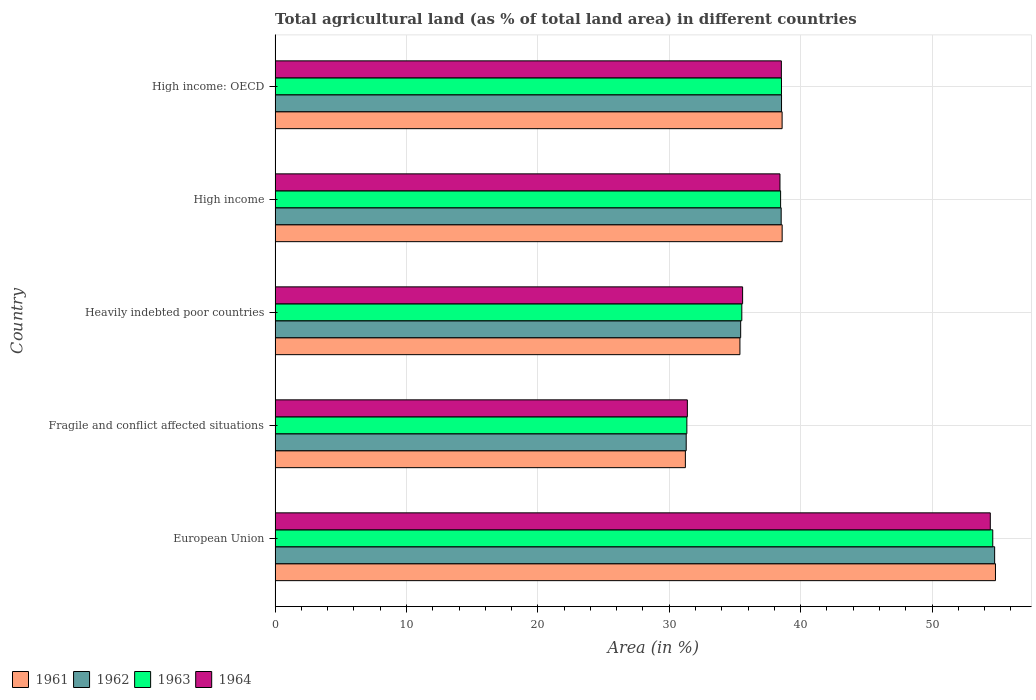How many different coloured bars are there?
Your response must be concise. 4. Are the number of bars on each tick of the Y-axis equal?
Your answer should be very brief. Yes. How many bars are there on the 5th tick from the top?
Your response must be concise. 4. What is the label of the 1st group of bars from the top?
Give a very brief answer. High income: OECD. In how many cases, is the number of bars for a given country not equal to the number of legend labels?
Your answer should be very brief. 0. What is the percentage of agricultural land in 1961 in High income: OECD?
Your response must be concise. 38.59. Across all countries, what is the maximum percentage of agricultural land in 1961?
Your response must be concise. 54.83. Across all countries, what is the minimum percentage of agricultural land in 1961?
Ensure brevity in your answer.  31.23. In which country was the percentage of agricultural land in 1963 maximum?
Provide a short and direct response. European Union. In which country was the percentage of agricultural land in 1964 minimum?
Offer a very short reply. Fragile and conflict affected situations. What is the total percentage of agricultural land in 1964 in the graph?
Your answer should be compact. 198.37. What is the difference between the percentage of agricultural land in 1961 in Fragile and conflict affected situations and that in High income?
Your response must be concise. -7.37. What is the difference between the percentage of agricultural land in 1962 in Fragile and conflict affected situations and the percentage of agricultural land in 1963 in European Union?
Provide a succinct answer. -23.33. What is the average percentage of agricultural land in 1964 per country?
Your response must be concise. 39.67. What is the difference between the percentage of agricultural land in 1963 and percentage of agricultural land in 1962 in European Union?
Make the answer very short. -0.14. What is the ratio of the percentage of agricultural land in 1962 in European Union to that in High income?
Offer a very short reply. 1.42. Is the percentage of agricultural land in 1964 in Fragile and conflict affected situations less than that in High income?
Your response must be concise. Yes. Is the difference between the percentage of agricultural land in 1963 in European Union and High income: OECD greater than the difference between the percentage of agricultural land in 1962 in European Union and High income: OECD?
Keep it short and to the point. No. What is the difference between the highest and the second highest percentage of agricultural land in 1961?
Your answer should be very brief. 16.24. What is the difference between the highest and the lowest percentage of agricultural land in 1961?
Give a very brief answer. 23.6. What does the 1st bar from the top in High income: OECD represents?
Your answer should be compact. 1964. What does the 3rd bar from the bottom in Fragile and conflict affected situations represents?
Your answer should be compact. 1963. How many countries are there in the graph?
Offer a very short reply. 5. Are the values on the major ticks of X-axis written in scientific E-notation?
Ensure brevity in your answer.  No. Does the graph contain any zero values?
Your answer should be very brief. No. Does the graph contain grids?
Provide a succinct answer. Yes. Where does the legend appear in the graph?
Give a very brief answer. Bottom left. How are the legend labels stacked?
Your answer should be compact. Horizontal. What is the title of the graph?
Your answer should be very brief. Total agricultural land (as % of total land area) in different countries. What is the label or title of the X-axis?
Your answer should be very brief. Area (in %). What is the Area (in %) in 1961 in European Union?
Keep it short and to the point. 54.83. What is the Area (in %) in 1962 in European Union?
Provide a succinct answer. 54.77. What is the Area (in %) of 1963 in European Union?
Keep it short and to the point. 54.63. What is the Area (in %) in 1964 in European Union?
Offer a terse response. 54.44. What is the Area (in %) in 1961 in Fragile and conflict affected situations?
Provide a succinct answer. 31.23. What is the Area (in %) in 1962 in Fragile and conflict affected situations?
Provide a succinct answer. 31.29. What is the Area (in %) of 1963 in Fragile and conflict affected situations?
Provide a succinct answer. 31.34. What is the Area (in %) in 1964 in Fragile and conflict affected situations?
Offer a terse response. 31.38. What is the Area (in %) in 1961 in Heavily indebted poor countries?
Provide a short and direct response. 35.38. What is the Area (in %) in 1962 in Heavily indebted poor countries?
Give a very brief answer. 35.44. What is the Area (in %) in 1963 in Heavily indebted poor countries?
Give a very brief answer. 35.52. What is the Area (in %) in 1964 in Heavily indebted poor countries?
Give a very brief answer. 35.59. What is the Area (in %) of 1961 in High income?
Make the answer very short. 38.59. What is the Area (in %) in 1962 in High income?
Ensure brevity in your answer.  38.52. What is the Area (in %) of 1963 in High income?
Provide a short and direct response. 38.48. What is the Area (in %) of 1964 in High income?
Your response must be concise. 38.43. What is the Area (in %) in 1961 in High income: OECD?
Give a very brief answer. 38.59. What is the Area (in %) in 1962 in High income: OECD?
Ensure brevity in your answer.  38.55. What is the Area (in %) of 1963 in High income: OECD?
Provide a succinct answer. 38.54. What is the Area (in %) of 1964 in High income: OECD?
Provide a succinct answer. 38.53. Across all countries, what is the maximum Area (in %) of 1961?
Your answer should be compact. 54.83. Across all countries, what is the maximum Area (in %) of 1962?
Your response must be concise. 54.77. Across all countries, what is the maximum Area (in %) in 1963?
Offer a terse response. 54.63. Across all countries, what is the maximum Area (in %) of 1964?
Provide a short and direct response. 54.44. Across all countries, what is the minimum Area (in %) in 1961?
Provide a short and direct response. 31.23. Across all countries, what is the minimum Area (in %) in 1962?
Your answer should be very brief. 31.29. Across all countries, what is the minimum Area (in %) in 1963?
Your answer should be very brief. 31.34. Across all countries, what is the minimum Area (in %) in 1964?
Your answer should be compact. 31.38. What is the total Area (in %) of 1961 in the graph?
Give a very brief answer. 198.63. What is the total Area (in %) in 1962 in the graph?
Offer a very short reply. 198.57. What is the total Area (in %) of 1963 in the graph?
Provide a succinct answer. 198.51. What is the total Area (in %) in 1964 in the graph?
Offer a terse response. 198.37. What is the difference between the Area (in %) of 1961 in European Union and that in Fragile and conflict affected situations?
Provide a succinct answer. 23.6. What is the difference between the Area (in %) in 1962 in European Union and that in Fragile and conflict affected situations?
Ensure brevity in your answer.  23.48. What is the difference between the Area (in %) of 1963 in European Union and that in Fragile and conflict affected situations?
Keep it short and to the point. 23.28. What is the difference between the Area (in %) in 1964 in European Union and that in Fragile and conflict affected situations?
Provide a short and direct response. 23.06. What is the difference between the Area (in %) in 1961 in European Union and that in Heavily indebted poor countries?
Your response must be concise. 19.45. What is the difference between the Area (in %) in 1962 in European Union and that in Heavily indebted poor countries?
Offer a very short reply. 19.33. What is the difference between the Area (in %) in 1963 in European Union and that in Heavily indebted poor countries?
Ensure brevity in your answer.  19.1. What is the difference between the Area (in %) in 1964 in European Union and that in Heavily indebted poor countries?
Your answer should be compact. 18.85. What is the difference between the Area (in %) of 1961 in European Union and that in High income?
Provide a succinct answer. 16.24. What is the difference between the Area (in %) in 1962 in European Union and that in High income?
Your answer should be compact. 16.25. What is the difference between the Area (in %) of 1963 in European Union and that in High income?
Give a very brief answer. 16.15. What is the difference between the Area (in %) of 1964 in European Union and that in High income?
Provide a succinct answer. 16.01. What is the difference between the Area (in %) of 1961 in European Union and that in High income: OECD?
Your answer should be compact. 16.24. What is the difference between the Area (in %) of 1962 in European Union and that in High income: OECD?
Your answer should be very brief. 16.22. What is the difference between the Area (in %) in 1963 in European Union and that in High income: OECD?
Give a very brief answer. 16.08. What is the difference between the Area (in %) in 1964 in European Union and that in High income: OECD?
Make the answer very short. 15.9. What is the difference between the Area (in %) of 1961 in Fragile and conflict affected situations and that in Heavily indebted poor countries?
Offer a very short reply. -4.15. What is the difference between the Area (in %) of 1962 in Fragile and conflict affected situations and that in Heavily indebted poor countries?
Your answer should be very brief. -4.15. What is the difference between the Area (in %) of 1963 in Fragile and conflict affected situations and that in Heavily indebted poor countries?
Your answer should be compact. -4.18. What is the difference between the Area (in %) of 1964 in Fragile and conflict affected situations and that in Heavily indebted poor countries?
Give a very brief answer. -4.21. What is the difference between the Area (in %) of 1961 in Fragile and conflict affected situations and that in High income?
Make the answer very short. -7.37. What is the difference between the Area (in %) of 1962 in Fragile and conflict affected situations and that in High income?
Your answer should be very brief. -7.23. What is the difference between the Area (in %) of 1963 in Fragile and conflict affected situations and that in High income?
Offer a very short reply. -7.14. What is the difference between the Area (in %) in 1964 in Fragile and conflict affected situations and that in High income?
Your answer should be very brief. -7.05. What is the difference between the Area (in %) of 1961 in Fragile and conflict affected situations and that in High income: OECD?
Offer a very short reply. -7.36. What is the difference between the Area (in %) in 1962 in Fragile and conflict affected situations and that in High income: OECD?
Provide a succinct answer. -7.26. What is the difference between the Area (in %) in 1963 in Fragile and conflict affected situations and that in High income: OECD?
Ensure brevity in your answer.  -7.2. What is the difference between the Area (in %) in 1964 in Fragile and conflict affected situations and that in High income: OECD?
Your answer should be very brief. -7.15. What is the difference between the Area (in %) in 1961 in Heavily indebted poor countries and that in High income?
Offer a terse response. -3.21. What is the difference between the Area (in %) in 1962 in Heavily indebted poor countries and that in High income?
Provide a short and direct response. -3.08. What is the difference between the Area (in %) in 1963 in Heavily indebted poor countries and that in High income?
Make the answer very short. -2.95. What is the difference between the Area (in %) of 1964 in Heavily indebted poor countries and that in High income?
Your response must be concise. -2.84. What is the difference between the Area (in %) in 1961 in Heavily indebted poor countries and that in High income: OECD?
Your answer should be compact. -3.21. What is the difference between the Area (in %) of 1962 in Heavily indebted poor countries and that in High income: OECD?
Offer a terse response. -3.11. What is the difference between the Area (in %) in 1963 in Heavily indebted poor countries and that in High income: OECD?
Keep it short and to the point. -3.02. What is the difference between the Area (in %) of 1964 in Heavily indebted poor countries and that in High income: OECD?
Ensure brevity in your answer.  -2.95. What is the difference between the Area (in %) of 1961 in High income and that in High income: OECD?
Offer a terse response. 0. What is the difference between the Area (in %) in 1962 in High income and that in High income: OECD?
Your answer should be compact. -0.03. What is the difference between the Area (in %) of 1963 in High income and that in High income: OECD?
Your response must be concise. -0.07. What is the difference between the Area (in %) in 1964 in High income and that in High income: OECD?
Offer a very short reply. -0.11. What is the difference between the Area (in %) in 1961 in European Union and the Area (in %) in 1962 in Fragile and conflict affected situations?
Give a very brief answer. 23.54. What is the difference between the Area (in %) of 1961 in European Union and the Area (in %) of 1963 in Fragile and conflict affected situations?
Provide a short and direct response. 23.49. What is the difference between the Area (in %) of 1961 in European Union and the Area (in %) of 1964 in Fragile and conflict affected situations?
Offer a very short reply. 23.45. What is the difference between the Area (in %) in 1962 in European Union and the Area (in %) in 1963 in Fragile and conflict affected situations?
Ensure brevity in your answer.  23.43. What is the difference between the Area (in %) in 1962 in European Union and the Area (in %) in 1964 in Fragile and conflict affected situations?
Offer a very short reply. 23.39. What is the difference between the Area (in %) of 1963 in European Union and the Area (in %) of 1964 in Fragile and conflict affected situations?
Make the answer very short. 23.25. What is the difference between the Area (in %) of 1961 in European Union and the Area (in %) of 1962 in Heavily indebted poor countries?
Provide a succinct answer. 19.39. What is the difference between the Area (in %) of 1961 in European Union and the Area (in %) of 1963 in Heavily indebted poor countries?
Offer a very short reply. 19.31. What is the difference between the Area (in %) in 1961 in European Union and the Area (in %) in 1964 in Heavily indebted poor countries?
Provide a short and direct response. 19.25. What is the difference between the Area (in %) of 1962 in European Union and the Area (in %) of 1963 in Heavily indebted poor countries?
Your answer should be very brief. 19.24. What is the difference between the Area (in %) in 1962 in European Union and the Area (in %) in 1964 in Heavily indebted poor countries?
Keep it short and to the point. 19.18. What is the difference between the Area (in %) of 1963 in European Union and the Area (in %) of 1964 in Heavily indebted poor countries?
Offer a terse response. 19.04. What is the difference between the Area (in %) in 1961 in European Union and the Area (in %) in 1962 in High income?
Your answer should be compact. 16.31. What is the difference between the Area (in %) in 1961 in European Union and the Area (in %) in 1963 in High income?
Make the answer very short. 16.35. What is the difference between the Area (in %) of 1961 in European Union and the Area (in %) of 1964 in High income?
Give a very brief answer. 16.4. What is the difference between the Area (in %) in 1962 in European Union and the Area (in %) in 1963 in High income?
Your answer should be very brief. 16.29. What is the difference between the Area (in %) of 1962 in European Union and the Area (in %) of 1964 in High income?
Your answer should be compact. 16.34. What is the difference between the Area (in %) of 1963 in European Union and the Area (in %) of 1964 in High income?
Offer a very short reply. 16.2. What is the difference between the Area (in %) in 1961 in European Union and the Area (in %) in 1962 in High income: OECD?
Give a very brief answer. 16.28. What is the difference between the Area (in %) of 1961 in European Union and the Area (in %) of 1963 in High income: OECD?
Make the answer very short. 16.29. What is the difference between the Area (in %) of 1961 in European Union and the Area (in %) of 1964 in High income: OECD?
Your response must be concise. 16.3. What is the difference between the Area (in %) of 1962 in European Union and the Area (in %) of 1963 in High income: OECD?
Provide a short and direct response. 16.22. What is the difference between the Area (in %) in 1962 in European Union and the Area (in %) in 1964 in High income: OECD?
Offer a very short reply. 16.23. What is the difference between the Area (in %) in 1963 in European Union and the Area (in %) in 1964 in High income: OECD?
Give a very brief answer. 16.09. What is the difference between the Area (in %) in 1961 in Fragile and conflict affected situations and the Area (in %) in 1962 in Heavily indebted poor countries?
Provide a succinct answer. -4.21. What is the difference between the Area (in %) in 1961 in Fragile and conflict affected situations and the Area (in %) in 1963 in Heavily indebted poor countries?
Keep it short and to the point. -4.3. What is the difference between the Area (in %) of 1961 in Fragile and conflict affected situations and the Area (in %) of 1964 in Heavily indebted poor countries?
Provide a succinct answer. -4.36. What is the difference between the Area (in %) of 1962 in Fragile and conflict affected situations and the Area (in %) of 1963 in Heavily indebted poor countries?
Your answer should be compact. -4.23. What is the difference between the Area (in %) of 1962 in Fragile and conflict affected situations and the Area (in %) of 1964 in Heavily indebted poor countries?
Provide a short and direct response. -4.29. What is the difference between the Area (in %) in 1963 in Fragile and conflict affected situations and the Area (in %) in 1964 in Heavily indebted poor countries?
Your response must be concise. -4.24. What is the difference between the Area (in %) in 1961 in Fragile and conflict affected situations and the Area (in %) in 1962 in High income?
Your answer should be compact. -7.29. What is the difference between the Area (in %) of 1961 in Fragile and conflict affected situations and the Area (in %) of 1963 in High income?
Offer a very short reply. -7.25. What is the difference between the Area (in %) in 1961 in Fragile and conflict affected situations and the Area (in %) in 1964 in High income?
Give a very brief answer. -7.2. What is the difference between the Area (in %) of 1962 in Fragile and conflict affected situations and the Area (in %) of 1963 in High income?
Keep it short and to the point. -7.19. What is the difference between the Area (in %) in 1962 in Fragile and conflict affected situations and the Area (in %) in 1964 in High income?
Give a very brief answer. -7.14. What is the difference between the Area (in %) in 1963 in Fragile and conflict affected situations and the Area (in %) in 1964 in High income?
Offer a terse response. -7.09. What is the difference between the Area (in %) of 1961 in Fragile and conflict affected situations and the Area (in %) of 1962 in High income: OECD?
Your answer should be very brief. -7.32. What is the difference between the Area (in %) in 1961 in Fragile and conflict affected situations and the Area (in %) in 1963 in High income: OECD?
Provide a short and direct response. -7.32. What is the difference between the Area (in %) of 1961 in Fragile and conflict affected situations and the Area (in %) of 1964 in High income: OECD?
Your response must be concise. -7.31. What is the difference between the Area (in %) of 1962 in Fragile and conflict affected situations and the Area (in %) of 1963 in High income: OECD?
Provide a succinct answer. -7.25. What is the difference between the Area (in %) of 1962 in Fragile and conflict affected situations and the Area (in %) of 1964 in High income: OECD?
Give a very brief answer. -7.24. What is the difference between the Area (in %) of 1963 in Fragile and conflict affected situations and the Area (in %) of 1964 in High income: OECD?
Your response must be concise. -7.19. What is the difference between the Area (in %) in 1961 in Heavily indebted poor countries and the Area (in %) in 1962 in High income?
Ensure brevity in your answer.  -3.14. What is the difference between the Area (in %) of 1961 in Heavily indebted poor countries and the Area (in %) of 1963 in High income?
Ensure brevity in your answer.  -3.1. What is the difference between the Area (in %) in 1961 in Heavily indebted poor countries and the Area (in %) in 1964 in High income?
Your answer should be very brief. -3.05. What is the difference between the Area (in %) of 1962 in Heavily indebted poor countries and the Area (in %) of 1963 in High income?
Give a very brief answer. -3.04. What is the difference between the Area (in %) in 1962 in Heavily indebted poor countries and the Area (in %) in 1964 in High income?
Provide a short and direct response. -2.99. What is the difference between the Area (in %) of 1963 in Heavily indebted poor countries and the Area (in %) of 1964 in High income?
Your response must be concise. -2.9. What is the difference between the Area (in %) in 1961 in Heavily indebted poor countries and the Area (in %) in 1962 in High income: OECD?
Offer a very short reply. -3.17. What is the difference between the Area (in %) of 1961 in Heavily indebted poor countries and the Area (in %) of 1963 in High income: OECD?
Offer a terse response. -3.16. What is the difference between the Area (in %) in 1961 in Heavily indebted poor countries and the Area (in %) in 1964 in High income: OECD?
Give a very brief answer. -3.15. What is the difference between the Area (in %) of 1962 in Heavily indebted poor countries and the Area (in %) of 1963 in High income: OECD?
Offer a terse response. -3.11. What is the difference between the Area (in %) of 1962 in Heavily indebted poor countries and the Area (in %) of 1964 in High income: OECD?
Your answer should be compact. -3.1. What is the difference between the Area (in %) in 1963 in Heavily indebted poor countries and the Area (in %) in 1964 in High income: OECD?
Offer a very short reply. -3.01. What is the difference between the Area (in %) of 1961 in High income and the Area (in %) of 1962 in High income: OECD?
Provide a succinct answer. 0.05. What is the difference between the Area (in %) of 1961 in High income and the Area (in %) of 1963 in High income: OECD?
Your answer should be compact. 0.05. What is the difference between the Area (in %) in 1961 in High income and the Area (in %) in 1964 in High income: OECD?
Offer a terse response. 0.06. What is the difference between the Area (in %) of 1962 in High income and the Area (in %) of 1963 in High income: OECD?
Offer a very short reply. -0.02. What is the difference between the Area (in %) of 1962 in High income and the Area (in %) of 1964 in High income: OECD?
Provide a succinct answer. -0.01. What is the difference between the Area (in %) in 1963 in High income and the Area (in %) in 1964 in High income: OECD?
Give a very brief answer. -0.06. What is the average Area (in %) in 1961 per country?
Make the answer very short. 39.73. What is the average Area (in %) of 1962 per country?
Your answer should be very brief. 39.71. What is the average Area (in %) of 1963 per country?
Ensure brevity in your answer.  39.7. What is the average Area (in %) in 1964 per country?
Your answer should be compact. 39.67. What is the difference between the Area (in %) in 1961 and Area (in %) in 1962 in European Union?
Make the answer very short. 0.06. What is the difference between the Area (in %) of 1961 and Area (in %) of 1963 in European Union?
Give a very brief answer. 0.21. What is the difference between the Area (in %) of 1961 and Area (in %) of 1964 in European Union?
Provide a succinct answer. 0.39. What is the difference between the Area (in %) in 1962 and Area (in %) in 1963 in European Union?
Ensure brevity in your answer.  0.14. What is the difference between the Area (in %) in 1962 and Area (in %) in 1964 in European Union?
Keep it short and to the point. 0.33. What is the difference between the Area (in %) of 1963 and Area (in %) of 1964 in European Union?
Provide a succinct answer. 0.19. What is the difference between the Area (in %) of 1961 and Area (in %) of 1962 in Fragile and conflict affected situations?
Make the answer very short. -0.06. What is the difference between the Area (in %) of 1961 and Area (in %) of 1963 in Fragile and conflict affected situations?
Keep it short and to the point. -0.11. What is the difference between the Area (in %) in 1961 and Area (in %) in 1964 in Fragile and conflict affected situations?
Ensure brevity in your answer.  -0.15. What is the difference between the Area (in %) of 1962 and Area (in %) of 1963 in Fragile and conflict affected situations?
Offer a terse response. -0.05. What is the difference between the Area (in %) of 1962 and Area (in %) of 1964 in Fragile and conflict affected situations?
Make the answer very short. -0.09. What is the difference between the Area (in %) of 1963 and Area (in %) of 1964 in Fragile and conflict affected situations?
Your answer should be very brief. -0.04. What is the difference between the Area (in %) in 1961 and Area (in %) in 1962 in Heavily indebted poor countries?
Offer a terse response. -0.06. What is the difference between the Area (in %) in 1961 and Area (in %) in 1963 in Heavily indebted poor countries?
Your answer should be very brief. -0.14. What is the difference between the Area (in %) in 1961 and Area (in %) in 1964 in Heavily indebted poor countries?
Offer a terse response. -0.2. What is the difference between the Area (in %) of 1962 and Area (in %) of 1963 in Heavily indebted poor countries?
Keep it short and to the point. -0.09. What is the difference between the Area (in %) of 1962 and Area (in %) of 1964 in Heavily indebted poor countries?
Ensure brevity in your answer.  -0.15. What is the difference between the Area (in %) of 1963 and Area (in %) of 1964 in Heavily indebted poor countries?
Your response must be concise. -0.06. What is the difference between the Area (in %) in 1961 and Area (in %) in 1962 in High income?
Provide a succinct answer. 0.07. What is the difference between the Area (in %) in 1961 and Area (in %) in 1963 in High income?
Keep it short and to the point. 0.12. What is the difference between the Area (in %) in 1961 and Area (in %) in 1964 in High income?
Make the answer very short. 0.17. What is the difference between the Area (in %) in 1962 and Area (in %) in 1963 in High income?
Your response must be concise. 0.04. What is the difference between the Area (in %) in 1962 and Area (in %) in 1964 in High income?
Provide a short and direct response. 0.09. What is the difference between the Area (in %) in 1963 and Area (in %) in 1964 in High income?
Offer a very short reply. 0.05. What is the difference between the Area (in %) of 1961 and Area (in %) of 1962 in High income: OECD?
Keep it short and to the point. 0.04. What is the difference between the Area (in %) of 1961 and Area (in %) of 1963 in High income: OECD?
Offer a terse response. 0.05. What is the difference between the Area (in %) of 1961 and Area (in %) of 1964 in High income: OECD?
Give a very brief answer. 0.06. What is the difference between the Area (in %) in 1962 and Area (in %) in 1963 in High income: OECD?
Make the answer very short. 0. What is the difference between the Area (in %) of 1962 and Area (in %) of 1964 in High income: OECD?
Your answer should be compact. 0.01. What is the difference between the Area (in %) in 1963 and Area (in %) in 1964 in High income: OECD?
Keep it short and to the point. 0.01. What is the ratio of the Area (in %) in 1961 in European Union to that in Fragile and conflict affected situations?
Your answer should be very brief. 1.76. What is the ratio of the Area (in %) of 1962 in European Union to that in Fragile and conflict affected situations?
Provide a short and direct response. 1.75. What is the ratio of the Area (in %) of 1963 in European Union to that in Fragile and conflict affected situations?
Provide a succinct answer. 1.74. What is the ratio of the Area (in %) of 1964 in European Union to that in Fragile and conflict affected situations?
Keep it short and to the point. 1.73. What is the ratio of the Area (in %) in 1961 in European Union to that in Heavily indebted poor countries?
Give a very brief answer. 1.55. What is the ratio of the Area (in %) in 1962 in European Union to that in Heavily indebted poor countries?
Your answer should be very brief. 1.55. What is the ratio of the Area (in %) in 1963 in European Union to that in Heavily indebted poor countries?
Keep it short and to the point. 1.54. What is the ratio of the Area (in %) in 1964 in European Union to that in Heavily indebted poor countries?
Offer a very short reply. 1.53. What is the ratio of the Area (in %) in 1961 in European Union to that in High income?
Your response must be concise. 1.42. What is the ratio of the Area (in %) of 1962 in European Union to that in High income?
Provide a succinct answer. 1.42. What is the ratio of the Area (in %) of 1963 in European Union to that in High income?
Your response must be concise. 1.42. What is the ratio of the Area (in %) of 1964 in European Union to that in High income?
Provide a succinct answer. 1.42. What is the ratio of the Area (in %) in 1961 in European Union to that in High income: OECD?
Provide a succinct answer. 1.42. What is the ratio of the Area (in %) of 1962 in European Union to that in High income: OECD?
Make the answer very short. 1.42. What is the ratio of the Area (in %) of 1963 in European Union to that in High income: OECD?
Keep it short and to the point. 1.42. What is the ratio of the Area (in %) of 1964 in European Union to that in High income: OECD?
Your answer should be compact. 1.41. What is the ratio of the Area (in %) of 1961 in Fragile and conflict affected situations to that in Heavily indebted poor countries?
Offer a terse response. 0.88. What is the ratio of the Area (in %) in 1962 in Fragile and conflict affected situations to that in Heavily indebted poor countries?
Your answer should be compact. 0.88. What is the ratio of the Area (in %) of 1963 in Fragile and conflict affected situations to that in Heavily indebted poor countries?
Your response must be concise. 0.88. What is the ratio of the Area (in %) of 1964 in Fragile and conflict affected situations to that in Heavily indebted poor countries?
Offer a terse response. 0.88. What is the ratio of the Area (in %) in 1961 in Fragile and conflict affected situations to that in High income?
Offer a terse response. 0.81. What is the ratio of the Area (in %) of 1962 in Fragile and conflict affected situations to that in High income?
Offer a terse response. 0.81. What is the ratio of the Area (in %) in 1963 in Fragile and conflict affected situations to that in High income?
Offer a terse response. 0.81. What is the ratio of the Area (in %) of 1964 in Fragile and conflict affected situations to that in High income?
Offer a very short reply. 0.82. What is the ratio of the Area (in %) in 1961 in Fragile and conflict affected situations to that in High income: OECD?
Keep it short and to the point. 0.81. What is the ratio of the Area (in %) in 1962 in Fragile and conflict affected situations to that in High income: OECD?
Provide a succinct answer. 0.81. What is the ratio of the Area (in %) in 1963 in Fragile and conflict affected situations to that in High income: OECD?
Provide a short and direct response. 0.81. What is the ratio of the Area (in %) in 1964 in Fragile and conflict affected situations to that in High income: OECD?
Your answer should be very brief. 0.81. What is the ratio of the Area (in %) in 1962 in Heavily indebted poor countries to that in High income?
Your answer should be very brief. 0.92. What is the ratio of the Area (in %) of 1963 in Heavily indebted poor countries to that in High income?
Provide a short and direct response. 0.92. What is the ratio of the Area (in %) in 1964 in Heavily indebted poor countries to that in High income?
Provide a short and direct response. 0.93. What is the ratio of the Area (in %) of 1961 in Heavily indebted poor countries to that in High income: OECD?
Offer a very short reply. 0.92. What is the ratio of the Area (in %) of 1962 in Heavily indebted poor countries to that in High income: OECD?
Make the answer very short. 0.92. What is the ratio of the Area (in %) of 1963 in Heavily indebted poor countries to that in High income: OECD?
Your answer should be compact. 0.92. What is the ratio of the Area (in %) of 1964 in Heavily indebted poor countries to that in High income: OECD?
Your answer should be very brief. 0.92. What is the ratio of the Area (in %) of 1962 in High income to that in High income: OECD?
Provide a succinct answer. 1. What is the difference between the highest and the second highest Area (in %) of 1961?
Offer a very short reply. 16.24. What is the difference between the highest and the second highest Area (in %) of 1962?
Give a very brief answer. 16.22. What is the difference between the highest and the second highest Area (in %) of 1963?
Offer a very short reply. 16.08. What is the difference between the highest and the second highest Area (in %) of 1964?
Ensure brevity in your answer.  15.9. What is the difference between the highest and the lowest Area (in %) in 1961?
Provide a short and direct response. 23.6. What is the difference between the highest and the lowest Area (in %) of 1962?
Provide a succinct answer. 23.48. What is the difference between the highest and the lowest Area (in %) in 1963?
Offer a terse response. 23.28. What is the difference between the highest and the lowest Area (in %) of 1964?
Offer a terse response. 23.06. 